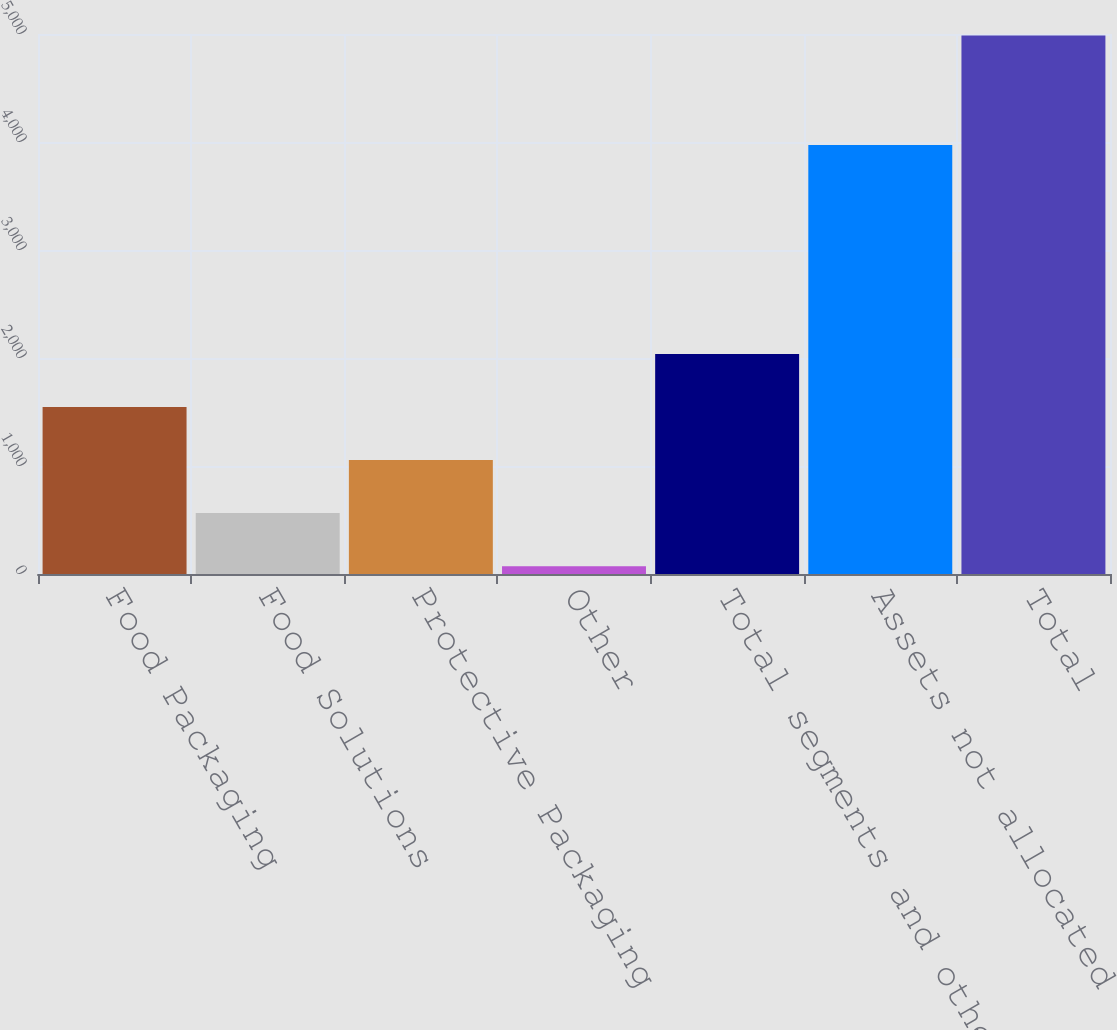<chart> <loc_0><loc_0><loc_500><loc_500><bar_chart><fcel>Food Packaging<fcel>Food Solutions<fcel>Protective Packaging<fcel>Other<fcel>Total segments and other<fcel>Assets not allocated<fcel>Total<nl><fcel>1546.55<fcel>563.85<fcel>1055.2<fcel>72.5<fcel>2037.9<fcel>3972.6<fcel>4986<nl></chart> 